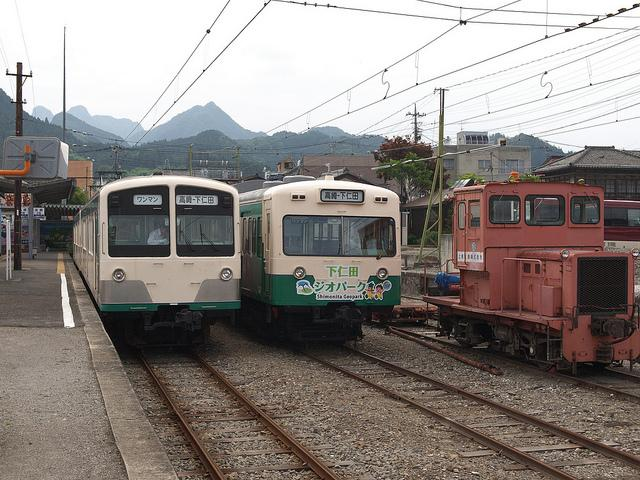What language is mainly spoken here?

Choices:
A) japanese
B) taiwanese
C) mandarin
D) korean japanese 